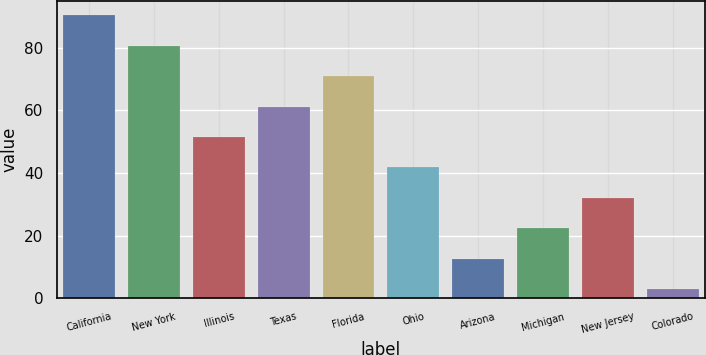<chart> <loc_0><loc_0><loc_500><loc_500><bar_chart><fcel>California<fcel>New York<fcel>Illinois<fcel>Texas<fcel>Florida<fcel>Ohio<fcel>Arizona<fcel>Michigan<fcel>New Jersey<fcel>Colorado<nl><fcel>90.3<fcel>80.6<fcel>51.5<fcel>61.2<fcel>70.9<fcel>41.8<fcel>12.7<fcel>22.4<fcel>32.1<fcel>3<nl></chart> 